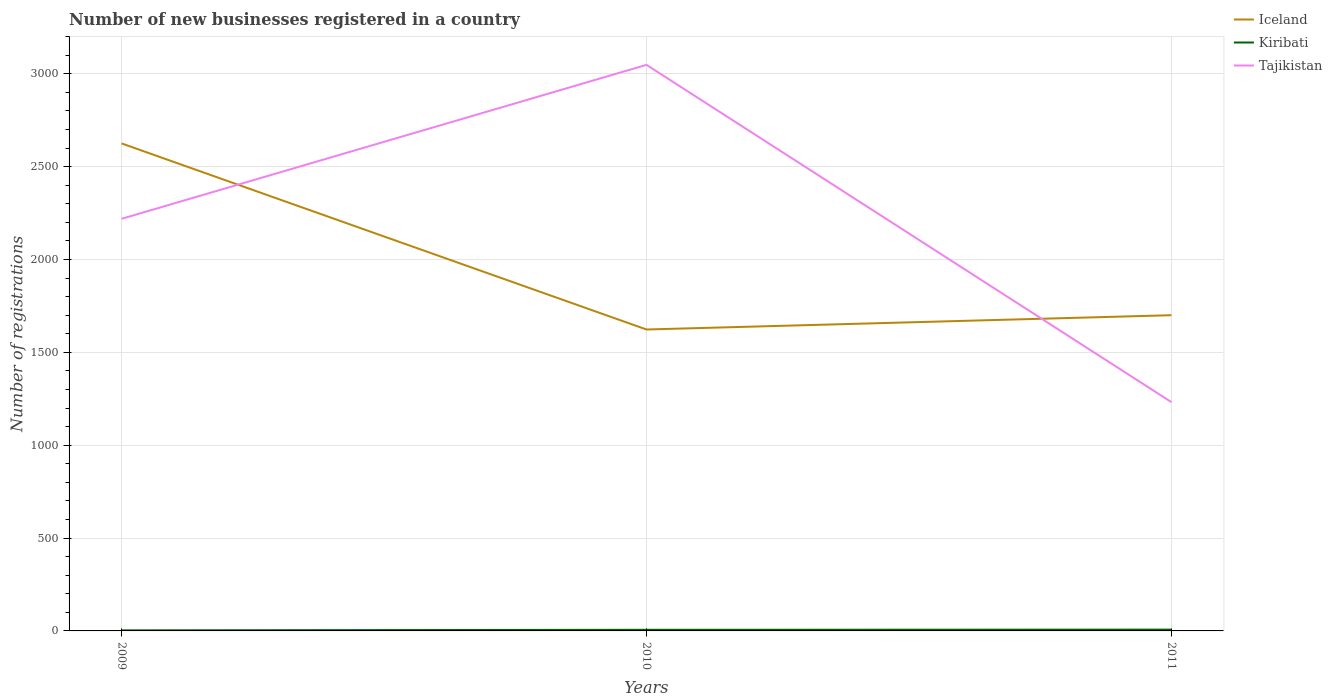How many different coloured lines are there?
Your answer should be compact. 3. Does the line corresponding to Iceland intersect with the line corresponding to Kiribati?
Offer a very short reply. No. Across all years, what is the maximum number of new businesses registered in Iceland?
Give a very brief answer. 1623. In which year was the number of new businesses registered in Kiribati maximum?
Your answer should be very brief. 2009. What is the total number of new businesses registered in Tajikistan in the graph?
Keep it short and to the point. 987. What is the difference between the highest and the second highest number of new businesses registered in Tajikistan?
Your response must be concise. 1816. What is the difference between two consecutive major ticks on the Y-axis?
Keep it short and to the point. 500. Are the values on the major ticks of Y-axis written in scientific E-notation?
Your answer should be very brief. No. Does the graph contain any zero values?
Provide a short and direct response. No. Does the graph contain grids?
Provide a short and direct response. Yes. Where does the legend appear in the graph?
Your response must be concise. Top right. What is the title of the graph?
Your response must be concise. Number of new businesses registered in a country. Does "Korea (Democratic)" appear as one of the legend labels in the graph?
Your response must be concise. No. What is the label or title of the X-axis?
Your response must be concise. Years. What is the label or title of the Y-axis?
Offer a terse response. Number of registrations. What is the Number of registrations in Iceland in 2009?
Provide a succinct answer. 2625. What is the Number of registrations of Kiribati in 2009?
Your answer should be compact. 3. What is the Number of registrations in Tajikistan in 2009?
Provide a short and direct response. 2219. What is the Number of registrations in Iceland in 2010?
Provide a short and direct response. 1623. What is the Number of registrations of Kiribati in 2010?
Provide a short and direct response. 6. What is the Number of registrations of Tajikistan in 2010?
Ensure brevity in your answer.  3048. What is the Number of registrations of Iceland in 2011?
Provide a succinct answer. 1700. What is the Number of registrations of Kiribati in 2011?
Your answer should be very brief. 7. What is the Number of registrations of Tajikistan in 2011?
Your answer should be very brief. 1232. Across all years, what is the maximum Number of registrations of Iceland?
Your response must be concise. 2625. Across all years, what is the maximum Number of registrations of Tajikistan?
Make the answer very short. 3048. Across all years, what is the minimum Number of registrations of Iceland?
Give a very brief answer. 1623. Across all years, what is the minimum Number of registrations in Kiribati?
Your answer should be very brief. 3. Across all years, what is the minimum Number of registrations in Tajikistan?
Your answer should be compact. 1232. What is the total Number of registrations in Iceland in the graph?
Keep it short and to the point. 5948. What is the total Number of registrations of Tajikistan in the graph?
Your answer should be very brief. 6499. What is the difference between the Number of registrations in Iceland in 2009 and that in 2010?
Make the answer very short. 1002. What is the difference between the Number of registrations in Kiribati in 2009 and that in 2010?
Ensure brevity in your answer.  -3. What is the difference between the Number of registrations of Tajikistan in 2009 and that in 2010?
Make the answer very short. -829. What is the difference between the Number of registrations in Iceland in 2009 and that in 2011?
Provide a short and direct response. 925. What is the difference between the Number of registrations of Kiribati in 2009 and that in 2011?
Give a very brief answer. -4. What is the difference between the Number of registrations in Tajikistan in 2009 and that in 2011?
Offer a terse response. 987. What is the difference between the Number of registrations in Iceland in 2010 and that in 2011?
Ensure brevity in your answer.  -77. What is the difference between the Number of registrations in Kiribati in 2010 and that in 2011?
Provide a short and direct response. -1. What is the difference between the Number of registrations of Tajikistan in 2010 and that in 2011?
Give a very brief answer. 1816. What is the difference between the Number of registrations in Iceland in 2009 and the Number of registrations in Kiribati in 2010?
Your answer should be compact. 2619. What is the difference between the Number of registrations in Iceland in 2009 and the Number of registrations in Tajikistan in 2010?
Make the answer very short. -423. What is the difference between the Number of registrations in Kiribati in 2009 and the Number of registrations in Tajikistan in 2010?
Keep it short and to the point. -3045. What is the difference between the Number of registrations of Iceland in 2009 and the Number of registrations of Kiribati in 2011?
Offer a terse response. 2618. What is the difference between the Number of registrations of Iceland in 2009 and the Number of registrations of Tajikistan in 2011?
Your response must be concise. 1393. What is the difference between the Number of registrations of Kiribati in 2009 and the Number of registrations of Tajikistan in 2011?
Provide a succinct answer. -1229. What is the difference between the Number of registrations in Iceland in 2010 and the Number of registrations in Kiribati in 2011?
Ensure brevity in your answer.  1616. What is the difference between the Number of registrations of Iceland in 2010 and the Number of registrations of Tajikistan in 2011?
Give a very brief answer. 391. What is the difference between the Number of registrations in Kiribati in 2010 and the Number of registrations in Tajikistan in 2011?
Ensure brevity in your answer.  -1226. What is the average Number of registrations in Iceland per year?
Your answer should be very brief. 1982.67. What is the average Number of registrations of Kiribati per year?
Ensure brevity in your answer.  5.33. What is the average Number of registrations of Tajikistan per year?
Offer a very short reply. 2166.33. In the year 2009, what is the difference between the Number of registrations of Iceland and Number of registrations of Kiribati?
Your response must be concise. 2622. In the year 2009, what is the difference between the Number of registrations of Iceland and Number of registrations of Tajikistan?
Your answer should be compact. 406. In the year 2009, what is the difference between the Number of registrations of Kiribati and Number of registrations of Tajikistan?
Offer a very short reply. -2216. In the year 2010, what is the difference between the Number of registrations of Iceland and Number of registrations of Kiribati?
Provide a short and direct response. 1617. In the year 2010, what is the difference between the Number of registrations in Iceland and Number of registrations in Tajikistan?
Keep it short and to the point. -1425. In the year 2010, what is the difference between the Number of registrations of Kiribati and Number of registrations of Tajikistan?
Your answer should be very brief. -3042. In the year 2011, what is the difference between the Number of registrations in Iceland and Number of registrations in Kiribati?
Provide a succinct answer. 1693. In the year 2011, what is the difference between the Number of registrations in Iceland and Number of registrations in Tajikistan?
Keep it short and to the point. 468. In the year 2011, what is the difference between the Number of registrations in Kiribati and Number of registrations in Tajikistan?
Your answer should be very brief. -1225. What is the ratio of the Number of registrations in Iceland in 2009 to that in 2010?
Give a very brief answer. 1.62. What is the ratio of the Number of registrations in Tajikistan in 2009 to that in 2010?
Your response must be concise. 0.73. What is the ratio of the Number of registrations of Iceland in 2009 to that in 2011?
Your answer should be compact. 1.54. What is the ratio of the Number of registrations of Kiribati in 2009 to that in 2011?
Your answer should be very brief. 0.43. What is the ratio of the Number of registrations in Tajikistan in 2009 to that in 2011?
Provide a short and direct response. 1.8. What is the ratio of the Number of registrations of Iceland in 2010 to that in 2011?
Your answer should be very brief. 0.95. What is the ratio of the Number of registrations of Tajikistan in 2010 to that in 2011?
Keep it short and to the point. 2.47. What is the difference between the highest and the second highest Number of registrations of Iceland?
Make the answer very short. 925. What is the difference between the highest and the second highest Number of registrations of Kiribati?
Give a very brief answer. 1. What is the difference between the highest and the second highest Number of registrations of Tajikistan?
Offer a very short reply. 829. What is the difference between the highest and the lowest Number of registrations of Iceland?
Ensure brevity in your answer.  1002. What is the difference between the highest and the lowest Number of registrations of Tajikistan?
Your response must be concise. 1816. 